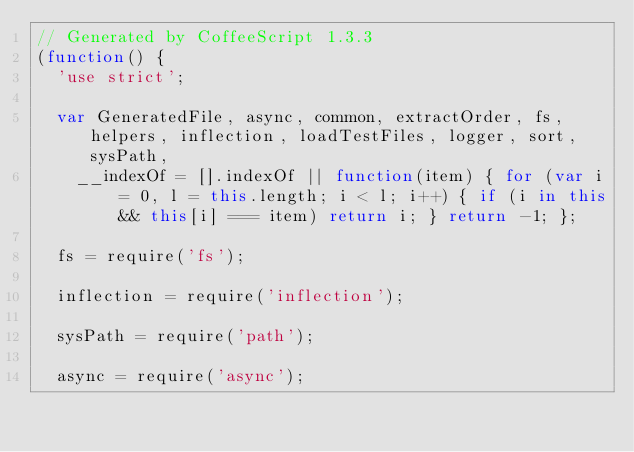<code> <loc_0><loc_0><loc_500><loc_500><_JavaScript_>// Generated by CoffeeScript 1.3.3
(function() {
  'use strict';

  var GeneratedFile, async, common, extractOrder, fs, helpers, inflection, loadTestFiles, logger, sort, sysPath,
    __indexOf = [].indexOf || function(item) { for (var i = 0, l = this.length; i < l; i++) { if (i in this && this[i] === item) return i; } return -1; };

  fs = require('fs');

  inflection = require('inflection');

  sysPath = require('path');

  async = require('async');
</code> 